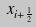Convert formula to latex. <formula><loc_0><loc_0><loc_500><loc_500>x _ { i + \frac { 1 } { 2 } }</formula> 